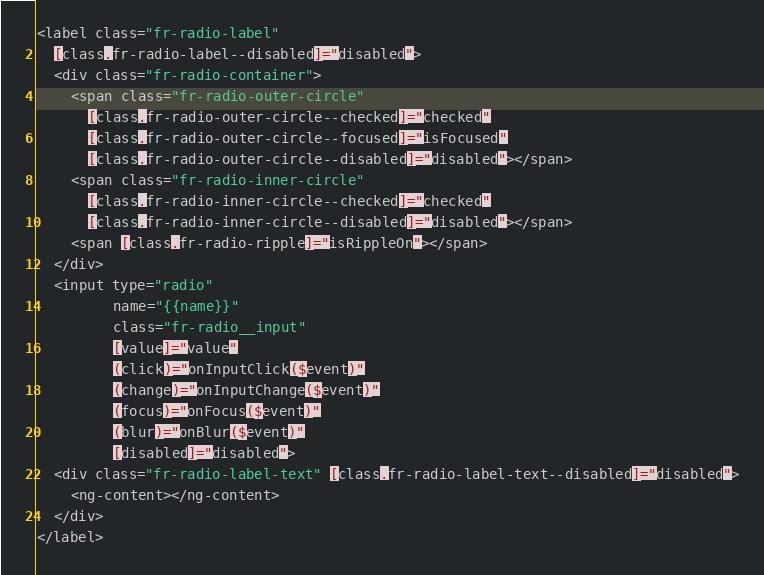<code> <loc_0><loc_0><loc_500><loc_500><_HTML_><label class="fr-radio-label"
  [class.fr-radio-label--disabled]="disabled">
  <div class="fr-radio-container">
    <span class="fr-radio-outer-circle"
      [class.fr-radio-outer-circle--checked]="checked"
      [class.fr-radio-outer-circle--focused]="isFocused"
      [class.fr-radio-outer-circle--disabled]="disabled"></span>
    <span class="fr-radio-inner-circle"
      [class.fr-radio-inner-circle--checked]="checked"
      [class.fr-radio-inner-circle--disabled]="disabled"></span>
    <span [class.fr-radio-ripple]="isRippleOn"></span>
  </div>
  <input type="radio"
         name="{{name}}"
         class="fr-radio__input"
         [value]="value"
         (click)="onInputClick($event)"
         (change)="onInputChange($event)"
         (focus)="onFocus($event)"
         (blur)="onBlur($event)"
         [disabled]="disabled">
  <div class="fr-radio-label-text" [class.fr-radio-label-text--disabled]="disabled">
    <ng-content></ng-content>
  </div>
</label>
</code> 